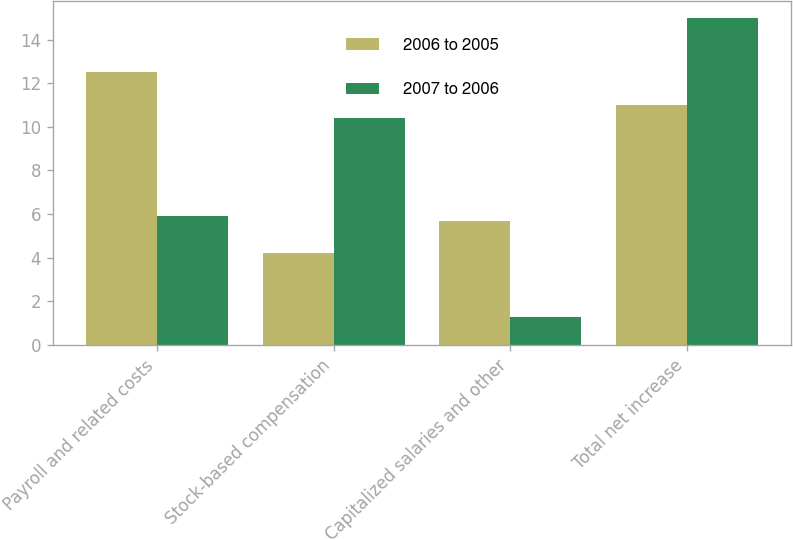Convert chart. <chart><loc_0><loc_0><loc_500><loc_500><stacked_bar_chart><ecel><fcel>Payroll and related costs<fcel>Stock-based compensation<fcel>Capitalized salaries and other<fcel>Total net increase<nl><fcel>2006 to 2005<fcel>12.5<fcel>4.2<fcel>5.7<fcel>11<nl><fcel>2007 to 2006<fcel>5.9<fcel>10.4<fcel>1.3<fcel>15<nl></chart> 